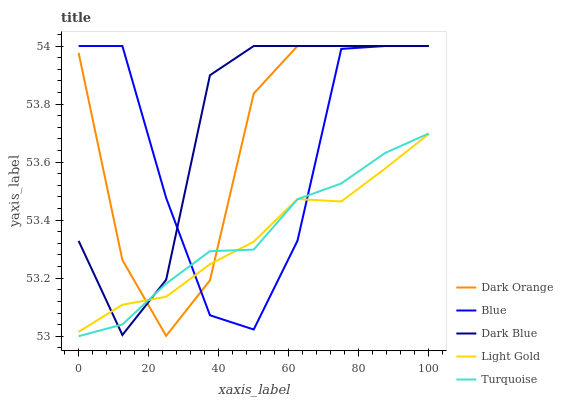Does Light Gold have the minimum area under the curve?
Answer yes or no. Yes. Does Dark Blue have the maximum area under the curve?
Answer yes or no. Yes. Does Dark Orange have the minimum area under the curve?
Answer yes or no. No. Does Dark Orange have the maximum area under the curve?
Answer yes or no. No. Is Light Gold the smoothest?
Answer yes or no. Yes. Is Blue the roughest?
Answer yes or no. Yes. Is Dark Orange the smoothest?
Answer yes or no. No. Is Dark Orange the roughest?
Answer yes or no. No. Does Dark Orange have the lowest value?
Answer yes or no. No. Does Dark Blue have the highest value?
Answer yes or no. Yes. Does Turquoise have the highest value?
Answer yes or no. No. Does Light Gold intersect Turquoise?
Answer yes or no. Yes. Is Light Gold less than Turquoise?
Answer yes or no. No. Is Light Gold greater than Turquoise?
Answer yes or no. No. 